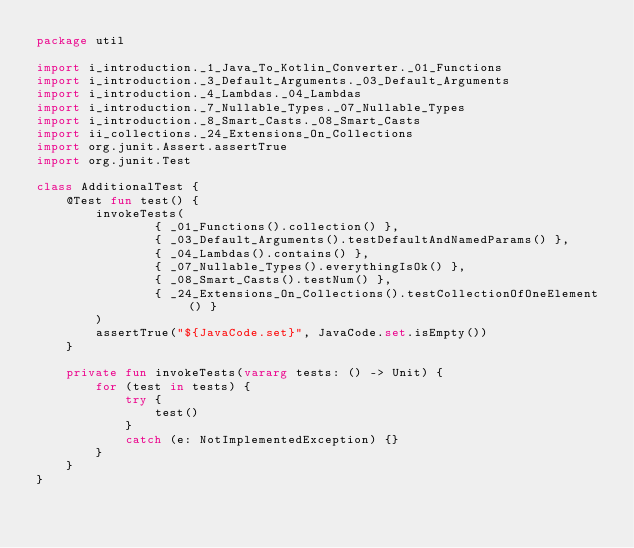Convert code to text. <code><loc_0><loc_0><loc_500><loc_500><_Kotlin_>package util

import i_introduction._1_Java_To_Kotlin_Converter._01_Functions
import i_introduction._3_Default_Arguments._03_Default_Arguments
import i_introduction._4_Lambdas._04_Lambdas
import i_introduction._7_Nullable_Types._07_Nullable_Types
import i_introduction._8_Smart_Casts._08_Smart_Casts
import ii_collections._24_Extensions_On_Collections
import org.junit.Assert.assertTrue
import org.junit.Test

class AdditionalTest {
    @Test fun test() {
        invokeTests(
                { _01_Functions().collection() },
                { _03_Default_Arguments().testDefaultAndNamedParams() },
                { _04_Lambdas().contains() },
                { _07_Nullable_Types().everythingIsOk() },
                { _08_Smart_Casts().testNum() },
                { _24_Extensions_On_Collections().testCollectionOfOneElement() }
        )
        assertTrue("${JavaCode.set}", JavaCode.set.isEmpty())
    }

    private fun invokeTests(vararg tests: () -> Unit) {
        for (test in tests) {
            try {
                test()
            }
            catch (e: NotImplementedException) {}
        }
    }
}

</code> 